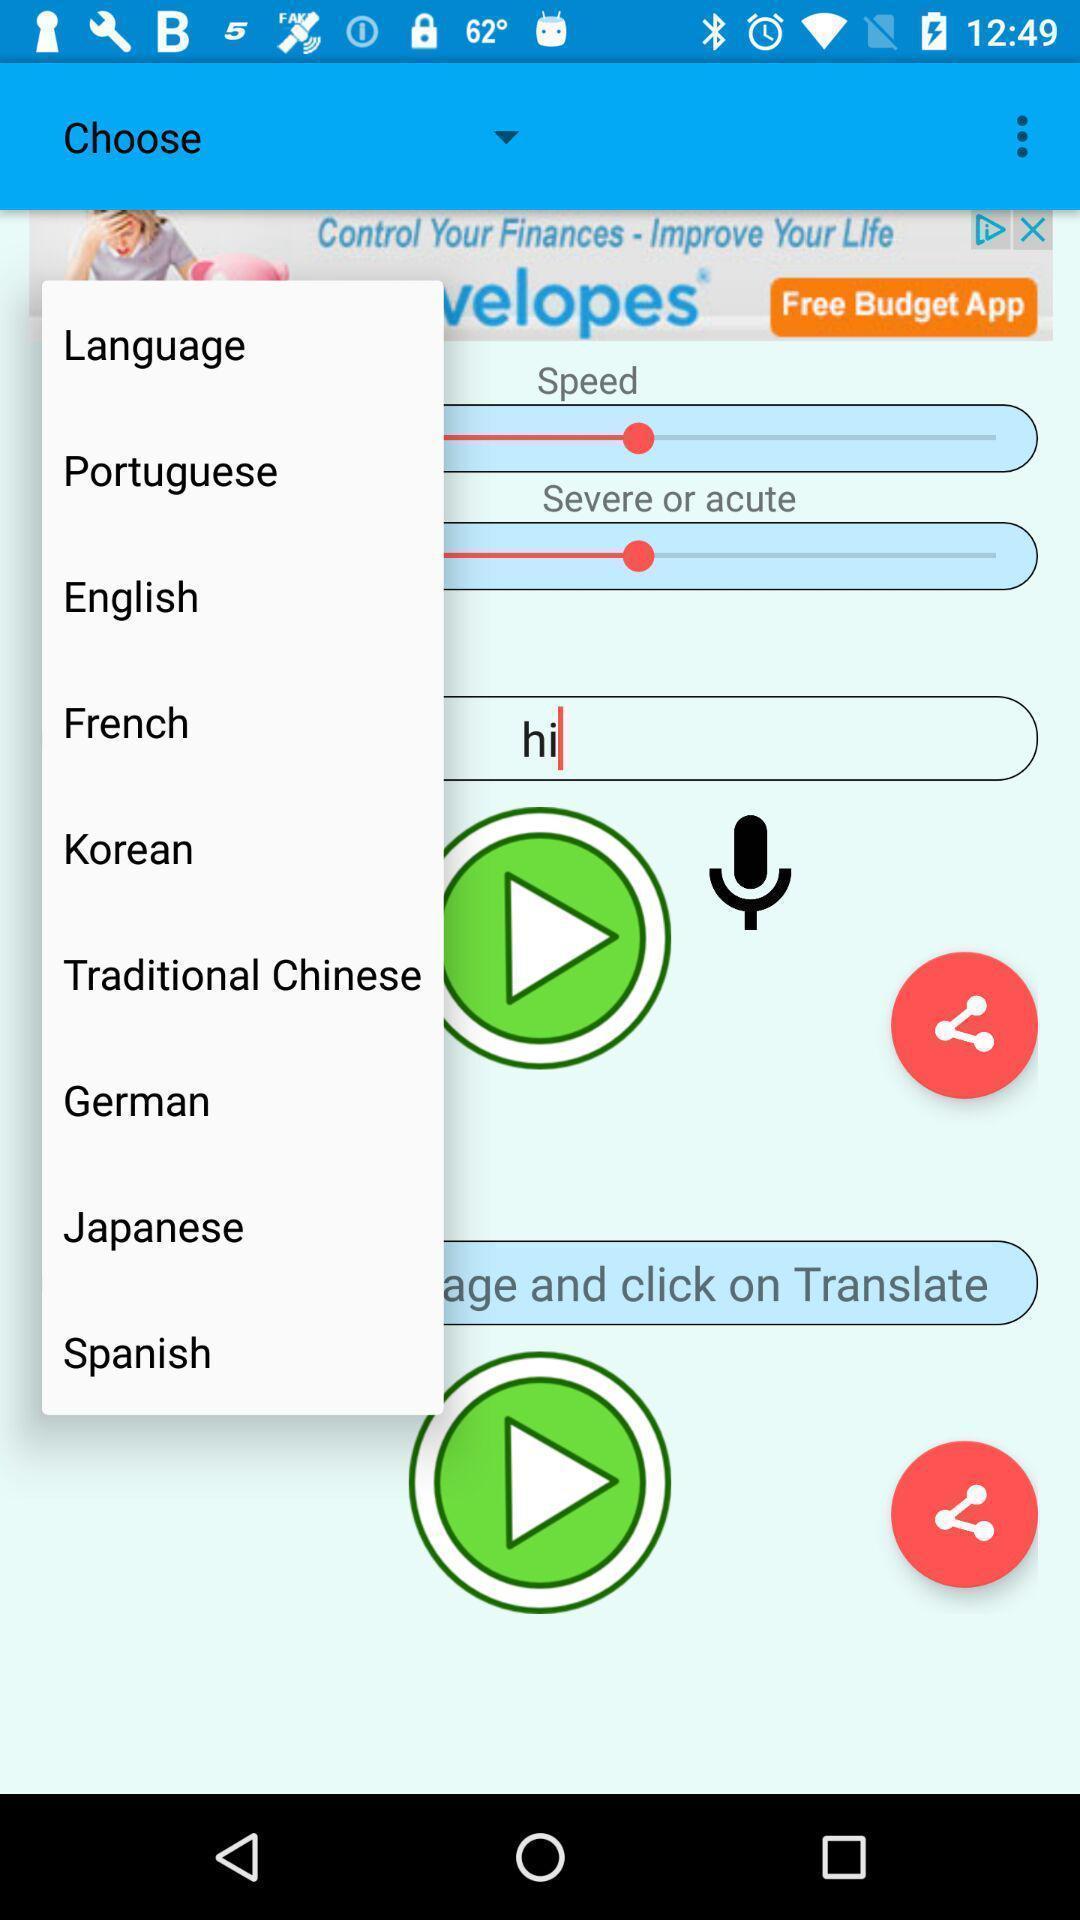Tell me what you see in this picture. Pop up displaying to choose a language. 